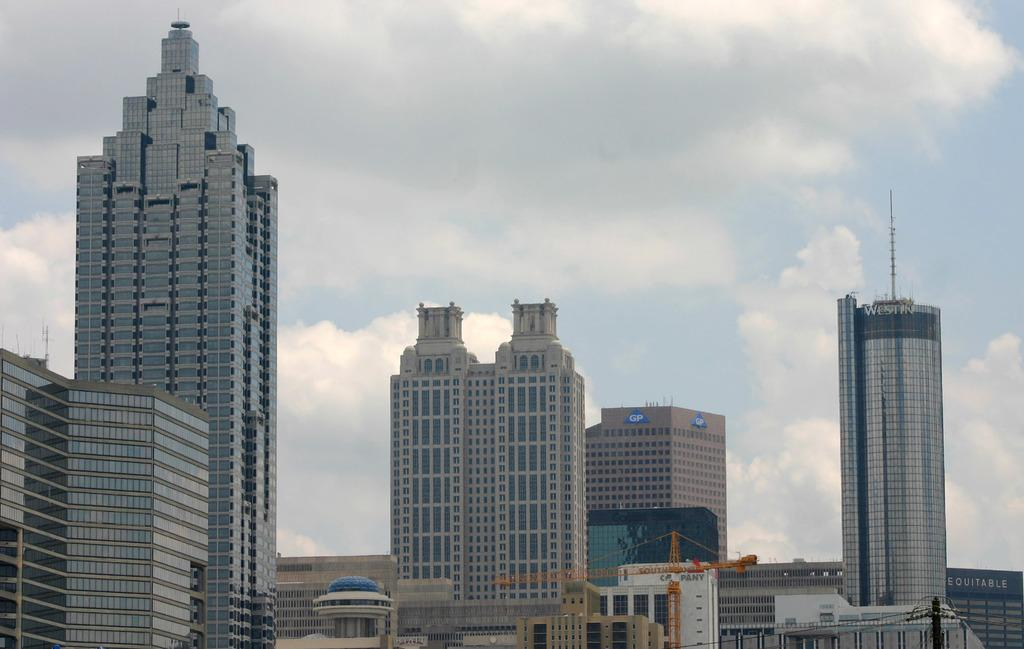What type of buildings can be seen in the foreground of the image? There are skyscrapers in the foreground of the image. What else is present in the foreground of the image besides the skyscrapers? There are poles in the foreground of the image. What can be seen in the background of the image? The sky is visible in the background of the image. What type of statement does the lawyer make in the image? There is no lawyer or statement present in the image. What scent can be detected in the image? There is no mention of any scent in the image. 